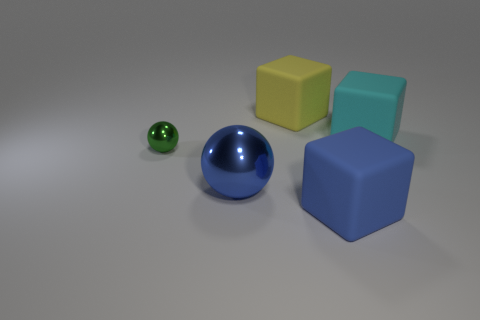Which of the objects in this image appears to have the smoothest surface? The large blue ball seems to have the smoothest surface, reflecting light uniformly and without texture. 